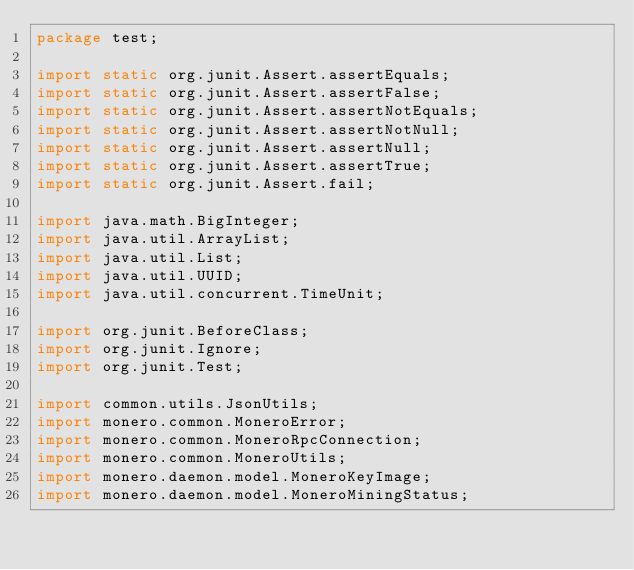Convert code to text. <code><loc_0><loc_0><loc_500><loc_500><_Java_>package test;

import static org.junit.Assert.assertEquals;
import static org.junit.Assert.assertFalse;
import static org.junit.Assert.assertNotEquals;
import static org.junit.Assert.assertNotNull;
import static org.junit.Assert.assertNull;
import static org.junit.Assert.assertTrue;
import static org.junit.Assert.fail;

import java.math.BigInteger;
import java.util.ArrayList;
import java.util.List;
import java.util.UUID;
import java.util.concurrent.TimeUnit;

import org.junit.BeforeClass;
import org.junit.Ignore;
import org.junit.Test;

import common.utils.JsonUtils;
import monero.common.MoneroError;
import monero.common.MoneroRpcConnection;
import monero.common.MoneroUtils;
import monero.daemon.model.MoneroKeyImage;
import monero.daemon.model.MoneroMiningStatus;</code> 